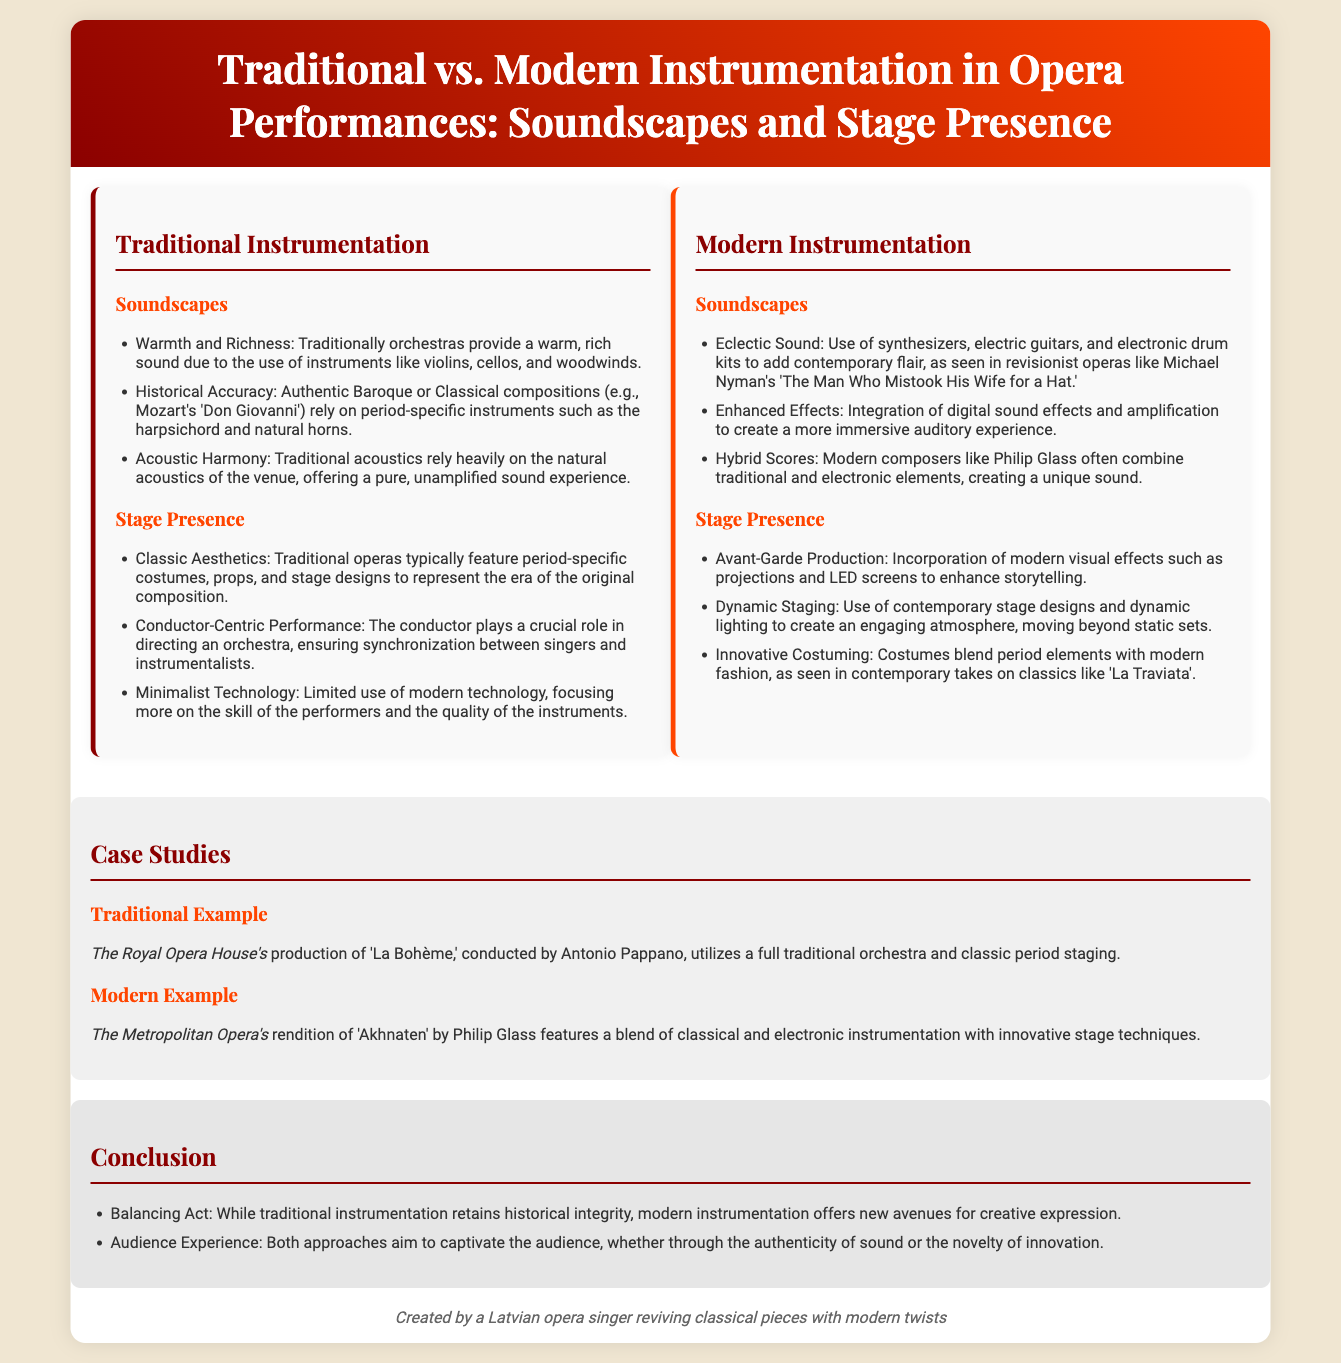What are the two main categories of instrumentation in the infographic? The infographic distinctly categorizes instrumentation into "Traditional" and "Modern."
Answer: Traditional, Modern Which traditional instrument is mentioned as providing historical accuracy? The document specifies that the harpsichord is an example of a period-specific instrument used for historical accuracy.
Answer: Harpsichord What phrase describes the sound quality provided by traditional orchestras? The document states that traditional orchestras provide a "warm, rich sound."
Answer: Warm, rich sound Who conducted the traditional production of 'La Bohème'? Antonio Pappano is mentioned as the conductor of the traditional production of 'La Bohème.'
Answer: Antonio Pappano What modern opera is highlighted in the case studies? The document identifies "Akhnaten" by Philip Glass as a prominent example of modern opera.
Answer: Akhnaten What is one key difference in stage presence between traditional and modern performances? Traditional performances focus on classic aesthetics, while modern performances adopt avant-garde production techniques.
Answer: Classic aesthetics, Avant-garde production What is a characteristic feature of modern soundscapes? The document notes that modern soundscapes often include "synthesizers, electric guitars, and electronic drum kits."
Answer: Synthesizers, electric guitars, electronic drum kits What modern technology is referenced in stage presence? The infographic mentions the use of modern visual effects, such as projections and LED screens.
Answer: Projections, LED screens What type of production does the modern example of 'Akhnaten' represent? The modern rendition of 'Akhnaten' illustrates a blend of classical and electronic instrumentation.
Answer: Blend of classical and electronic Which iconic venue is associated with the case study for traditional opera? The Royal Opera House is the venue associated with the case study for traditional opera in the document.
Answer: Royal Opera House 